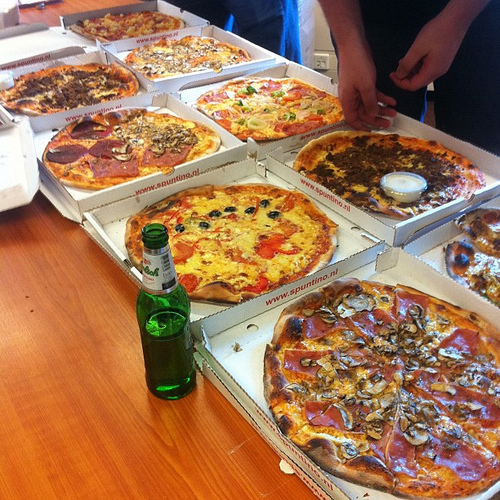Describe the beverage bottle in the image. The beverage bottle in the image is green and appears to be a glass bottle. It's placed in the foreground, on the left side of the image, standing tall amidst the pizzas. What would an ideal meal setting be with these pizzas, considering we are at a party? An ideal meal setting would be at a large, rustic wooden table surrounded by friends and family. The pizzas would be spread out attractively, accompanied by a variety of dipping sauces, salads, and a selection of beverages including sodas, beers, and perhaps some wine. There would be soft ambient music in the background, lively conversations, and lots of laughter, creating the perfect party atmosphere. If one of the pizzas in this image was renamed as 'Galaxy Delight,' what toppings would it have? The 'Galaxy Delight' pizza would have a myriad of colorful toppings representing the universe's wonders. It would include exotic purple sweet potatoes, bright yellow bell peppers, deep red sun-dried tomatoes, creamy mozzarella swirls resembling galaxies, and a sprinkling of edible glitter to mimic the stars. 